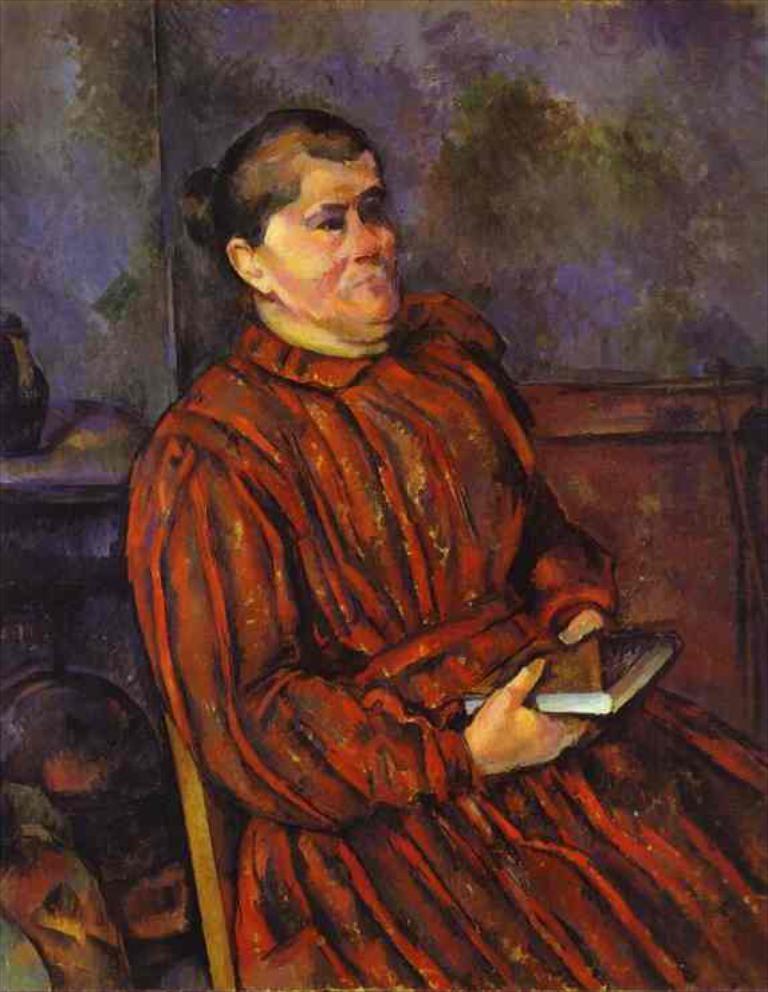Can you describe this image briefly? In this image we can see a painting of a person sitting on the chair and holding a book, we also can see the wall. 